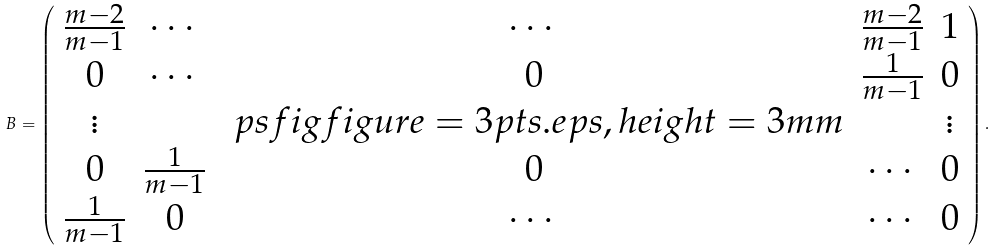<formula> <loc_0><loc_0><loc_500><loc_500>B = \left ( \begin{array} { c c c c c } \frac { m - 2 } { m - 1 } & \cdots & \cdots & \frac { m - 2 } { m - 1 } & 1 \\ 0 & \cdots & 0 & \frac { 1 } { m - 1 } & 0 \\ \vdots & & \ p s f i g { f i g u r e = 3 p t s . e p s , h e i g h t = 3 m m } & & \vdots \\ 0 & \frac { 1 } { m - 1 } & 0 & \cdots & 0 \\ \frac { 1 } { m - 1 } & 0 & \cdots & \cdots & 0 \end{array} \right ) .</formula> 